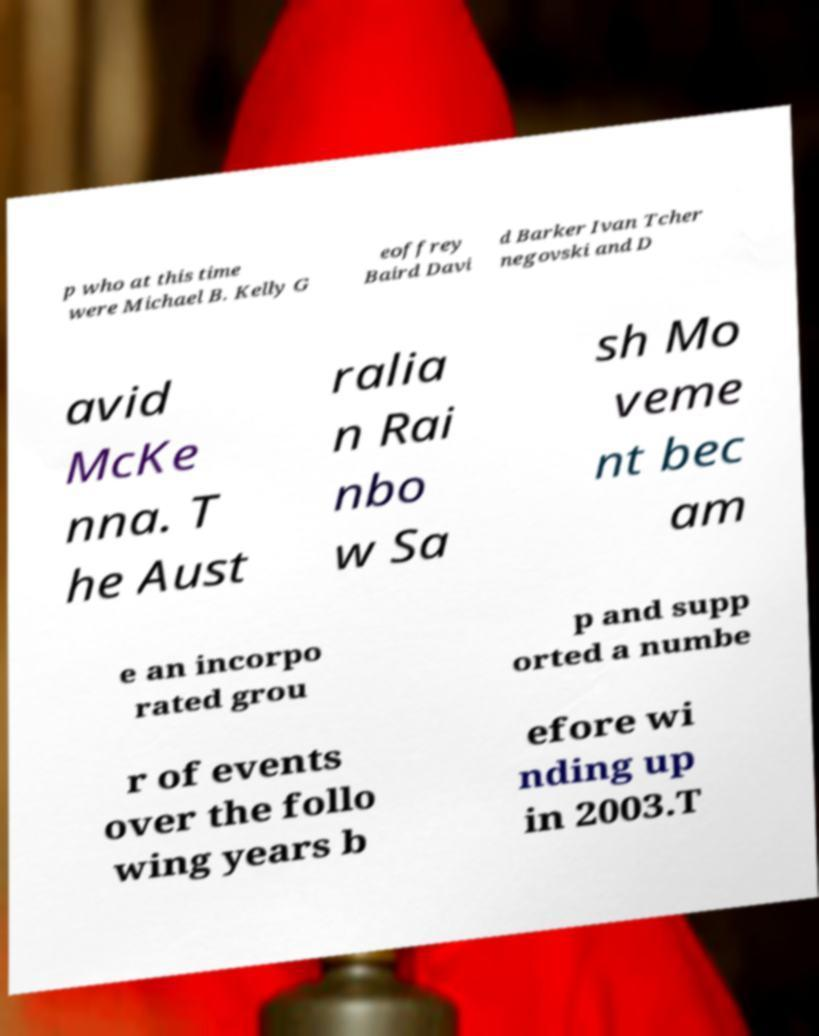Can you read and provide the text displayed in the image?This photo seems to have some interesting text. Can you extract and type it out for me? p who at this time were Michael B. Kelly G eoffrey Baird Davi d Barker Ivan Tcher negovski and D avid McKe nna. T he Aust ralia n Rai nbo w Sa sh Mo veme nt bec am e an incorpo rated grou p and supp orted a numbe r of events over the follo wing years b efore wi nding up in 2003.T 